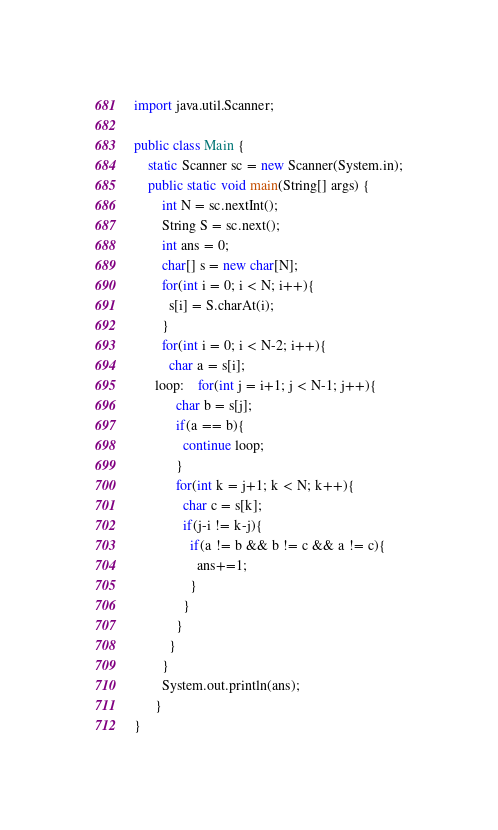Convert code to text. <code><loc_0><loc_0><loc_500><loc_500><_Java_>import java.util.Scanner;

public class Main {
    static Scanner sc = new Scanner(System.in);
    public static void main(String[] args) {
        int N = sc.nextInt();
        String S = sc.next();
        int ans = 0;
        char[] s = new char[N];
        for(int i = 0; i < N; i++){
          s[i] = S.charAt(i);
        }
        for(int i = 0; i < N-2; i++){
          char a = s[i];
      loop:    for(int j = i+1; j < N-1; j++){
            char b = s[j];
            if(a == b){
              continue loop;
            }
            for(int k = j+1; k < N; k++){
              char c = s[k];
              if(j-i != k-j){
                if(a != b && b != c && a != c){
                  ans+=1;
                }
              }
            }
          }
        }
        System.out.println(ans);
      }
}
</code> 